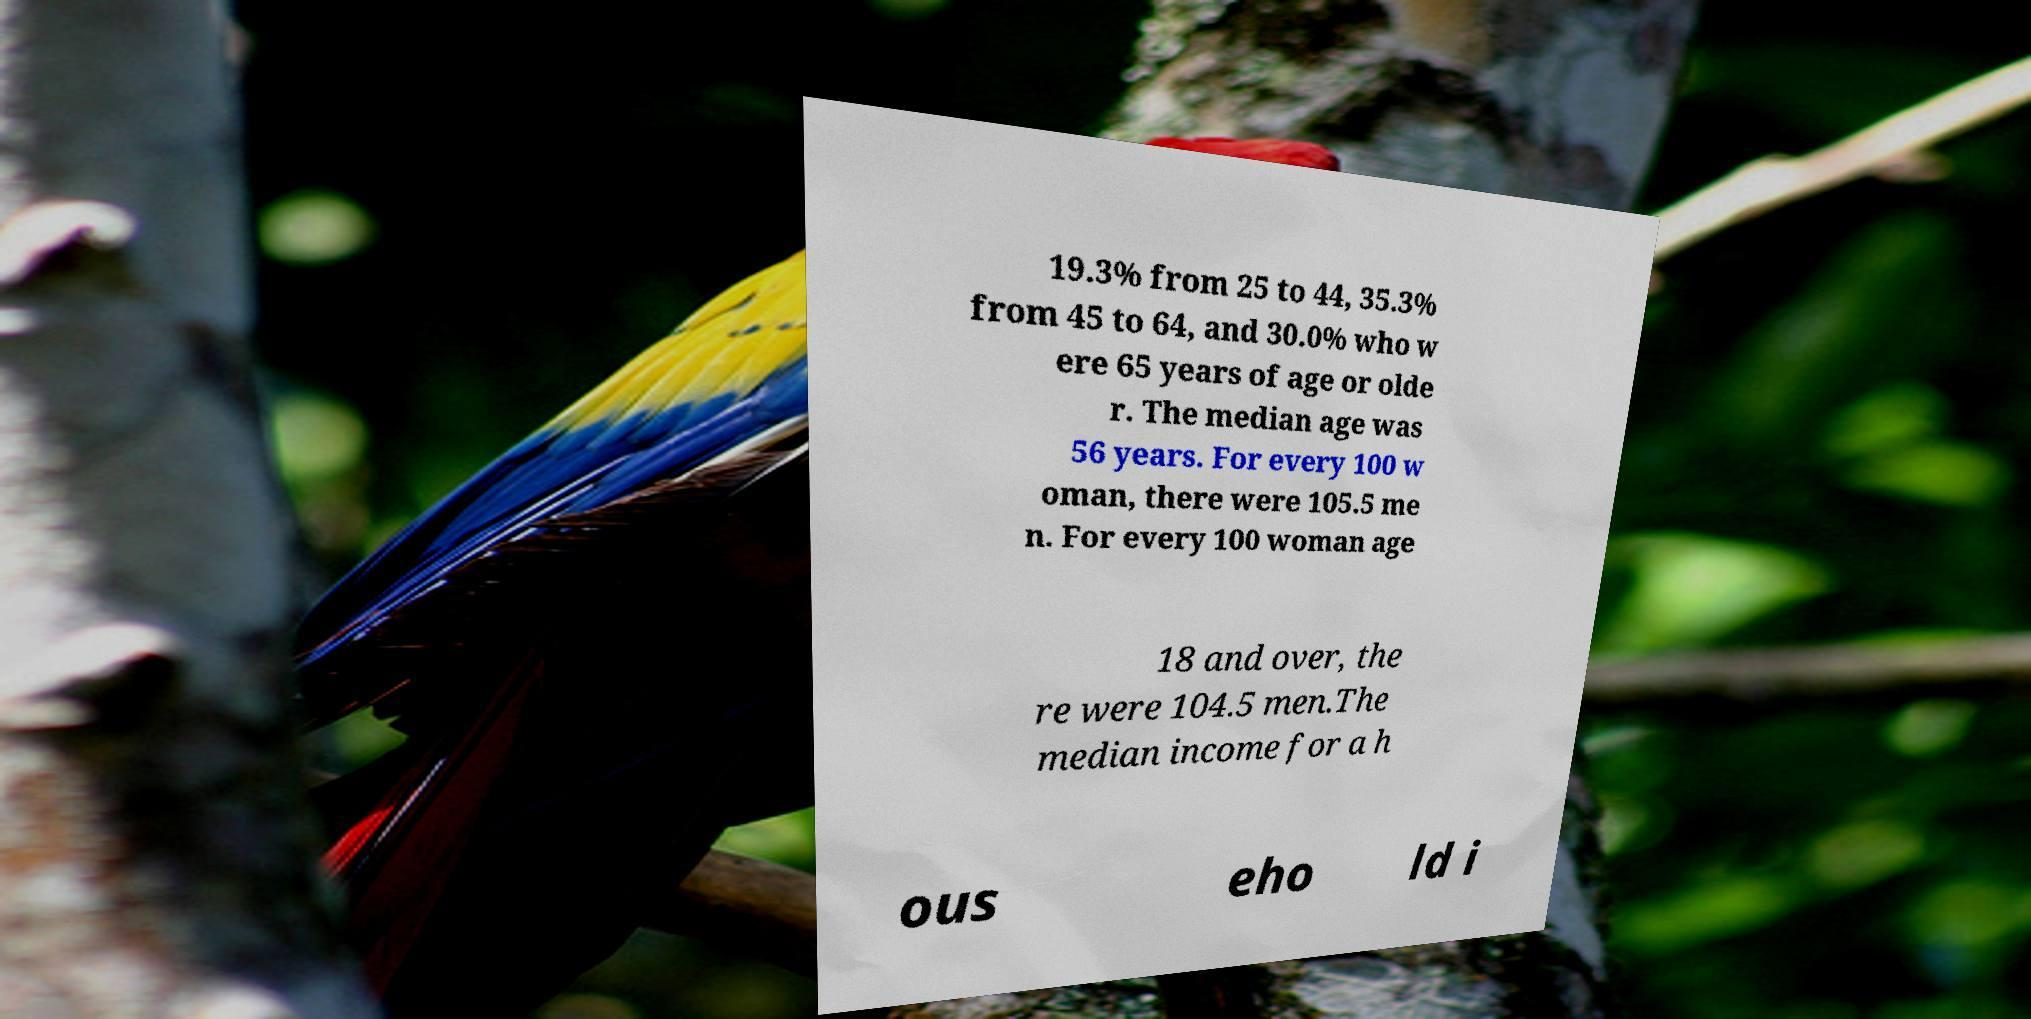I need the written content from this picture converted into text. Can you do that? 19.3% from 25 to 44, 35.3% from 45 to 64, and 30.0% who w ere 65 years of age or olde r. The median age was 56 years. For every 100 w oman, there were 105.5 me n. For every 100 woman age 18 and over, the re were 104.5 men.The median income for a h ous eho ld i 